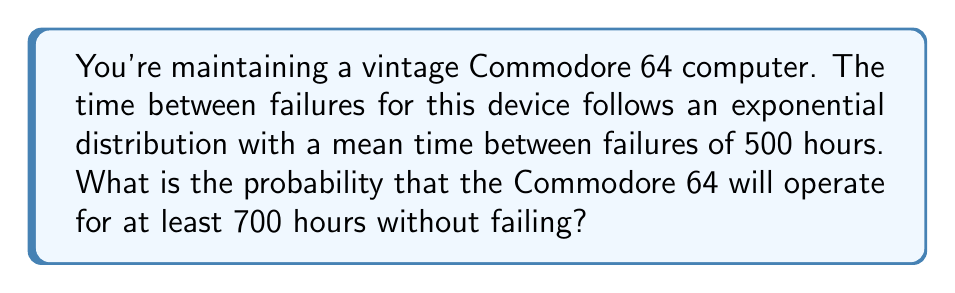Show me your answer to this math problem. Let's approach this step-by-step:

1) The exponential distribution is often used to model the time between events in a Poisson process. In this case, it's modeling the time between failures of the Commodore 64.

2) The probability density function of an exponential distribution is:

   $$f(x) = \lambda e^{-\lambda x}$$

   where $\lambda$ is the rate parameter.

3) We're given the mean time between failures, which for an exponential distribution is $\frac{1}{\lambda}$. So:

   $$\frac{1}{\lambda} = 500$$
   $$\lambda = \frac{1}{500} = 0.002$$

4) We want to find the probability that the time until failure is greater than 700 hours. This is the complement of the cumulative distribution function:

   $$P(X > 700) = 1 - P(X \leq 700) = 1 - (1 - e^{-\lambda x})$$

5) Substituting our values:

   $$P(X > 700) = 1 - (1 - e^{-0.002 * 700})$$
   $$= e^{-0.002 * 700}$$
   $$= e^{-1.4}$$

6) Calculating this:

   $$e^{-1.4} \approx 0.2466$$

Therefore, the probability that the Commodore 64 will operate for at least 700 hours without failing is approximately 0.2466 or 24.66%.
Answer: 0.2466 